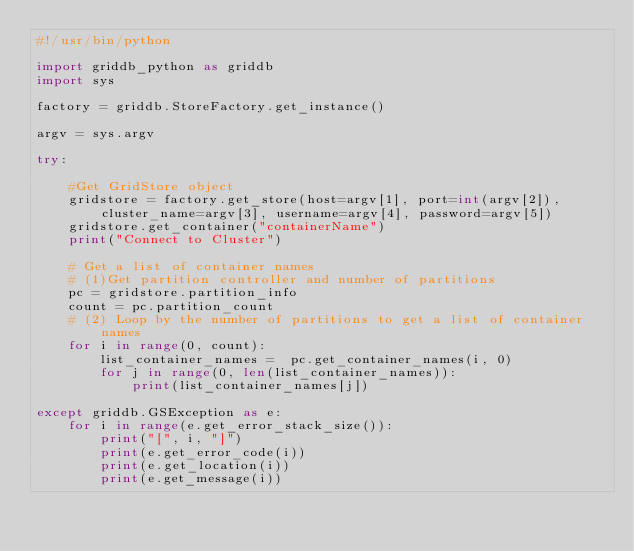Convert code to text. <code><loc_0><loc_0><loc_500><loc_500><_Python_>#!/usr/bin/python

import griddb_python as griddb
import sys

factory = griddb.StoreFactory.get_instance()

argv = sys.argv

try:

    #Get GridStore object
    gridstore = factory.get_store(host=argv[1], port=int(argv[2]), cluster_name=argv[3], username=argv[4], password=argv[5])
    gridstore.get_container("containerName")
    print("Connect to Cluster")

    # Get a list of container names
    # (1)Get partition controller and number of partitions
    pc = gridstore.partition_info
    count = pc.partition_count
    # (2) Loop by the number of partitions to get a list of container names
    for i in range(0, count):
        list_container_names =  pc.get_container_names(i, 0)
        for j in range(0, len(list_container_names)):
            print(list_container_names[j])

except griddb.GSException as e:
    for i in range(e.get_error_stack_size()):
        print("[", i, "]")
        print(e.get_error_code(i))
        print(e.get_location(i))
        print(e.get_message(i))
</code> 